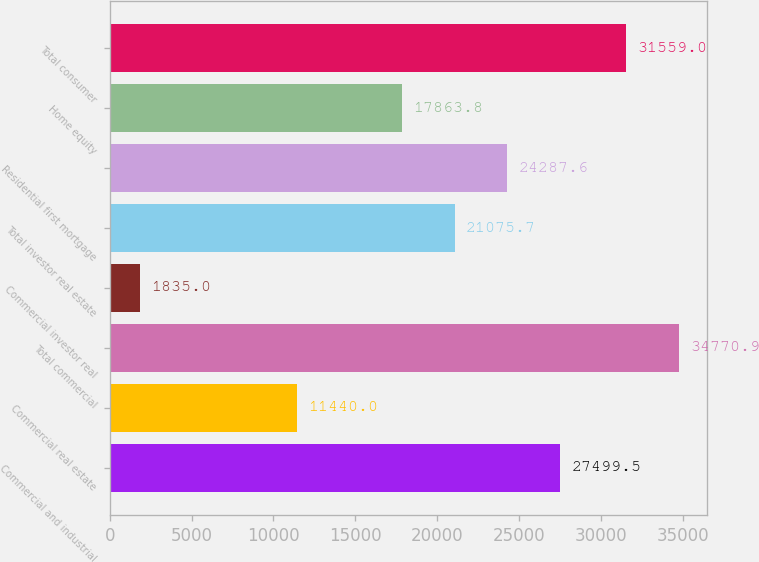Convert chart. <chart><loc_0><loc_0><loc_500><loc_500><bar_chart><fcel>Commercial and industrial<fcel>Commercial real estate<fcel>Total commercial<fcel>Commercial investor real<fcel>Total investor real estate<fcel>Residential first mortgage<fcel>Home equity<fcel>Total consumer<nl><fcel>27499.5<fcel>11440<fcel>34770.9<fcel>1835<fcel>21075.7<fcel>24287.6<fcel>17863.8<fcel>31559<nl></chart> 